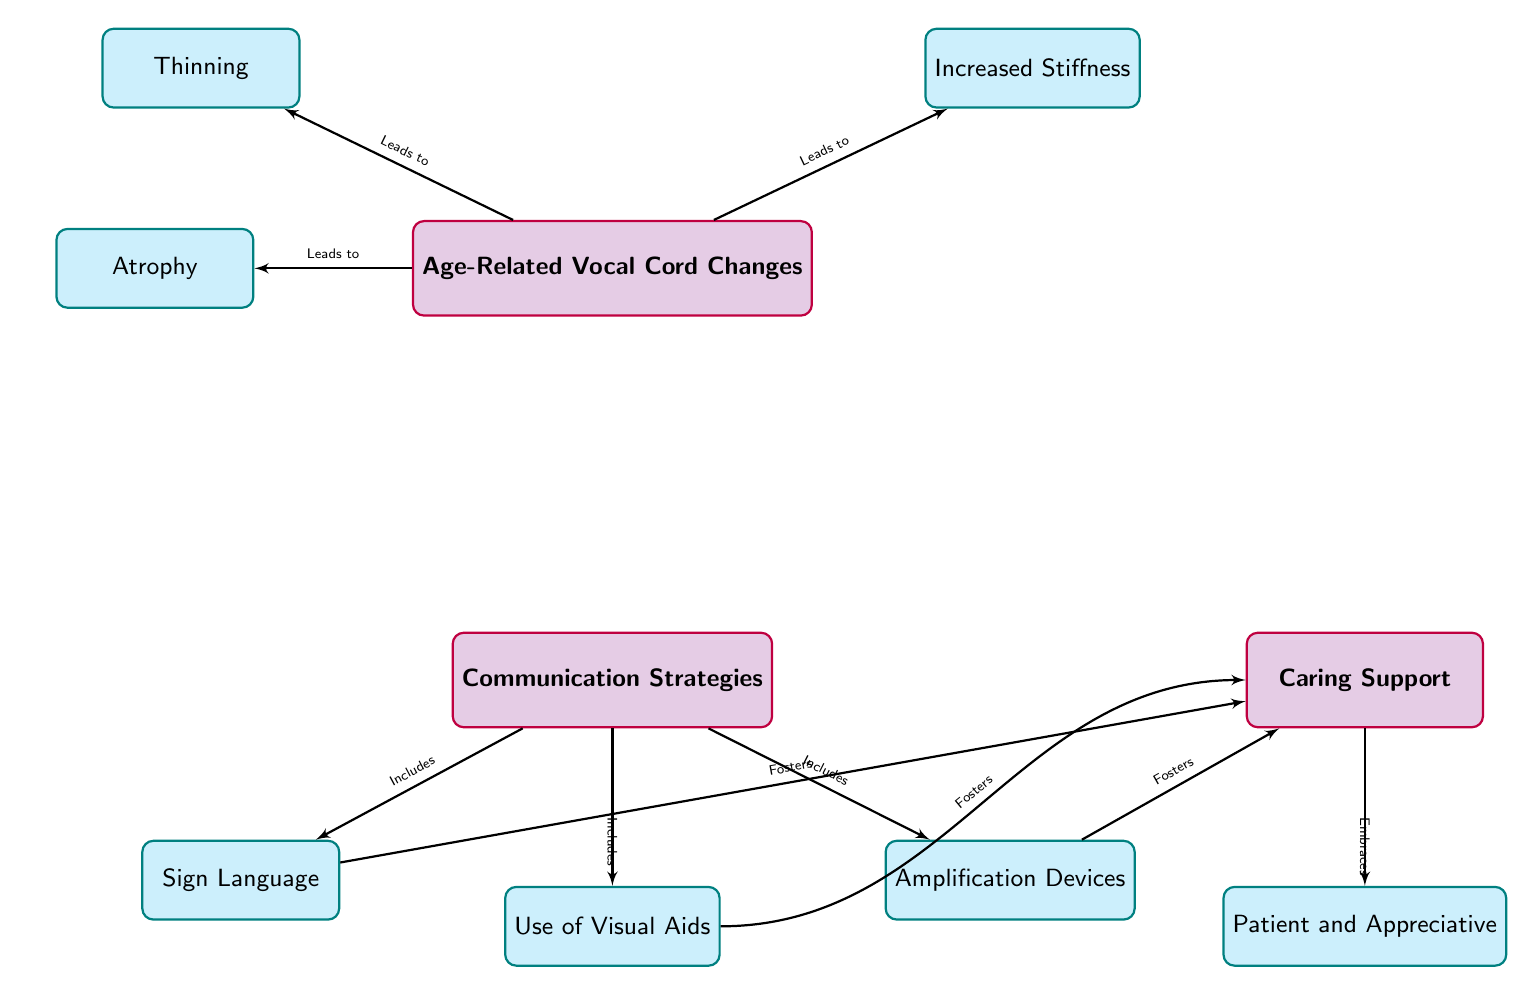What are the three changes listed under Age-Related Vocal Cord Changes? The three changes are Thinning, Atrophy, and Increased Stiffness. These are specifically noted as nodes branching from the main node labeled Age-Related Vocal Cord Changes in the diagram.
Answer: Thinning, Atrophy, Increased Stiffness How many communication strategies are mentioned in the diagram? The diagram lists three communication strategies which are Sign Language, Use of Visual Aids, and Amplification Devices. This count is based on the main node labeled Communication Strategies and the three nodes branching from it.
Answer: 3 What does "Age-Related Vocal Cord Changes" lead to? "Age-Related Vocal Cord Changes" leads to three distinct changes: Thinning, Atrophy, and Increased Stiffness, as indicated by the arrows leading from the main node to the three changes in the diagram.
Answer: Thinning, Atrophy, Increased Stiffness What role does "Caring Support" play in communication strategies? "Caring Support" is connected to therapy of communication strategies by fostering all three methods: Sign Language, Use of Visual Aids, and Amplification Devices. This shows that caring support is seen as a necessary element that enhances these strategies.
Answer: Fosters Which communication strategy is linked to both Sign Language and Amplification Devices? Use of Visual Aids connects Sign Language and Amplification Devices, as it is one of the main strategies listed and has edges leading towards Caring Support, which is influenced by Sign Language and Amplification Devices.
Answer: Use of Visual Aids 